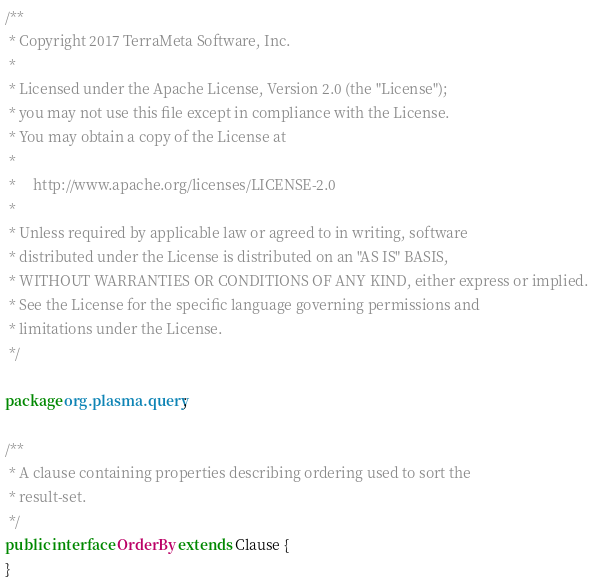Convert code to text. <code><loc_0><loc_0><loc_500><loc_500><_Java_>/**
 * Copyright 2017 TerraMeta Software, Inc.
 * 
 * Licensed under the Apache License, Version 2.0 (the "License");
 * you may not use this file except in compliance with the License.
 * You may obtain a copy of the License at
 * 
 *     http://www.apache.org/licenses/LICENSE-2.0
 * 
 * Unless required by applicable law or agreed to in writing, software
 * distributed under the License is distributed on an "AS IS" BASIS,
 * WITHOUT WARRANTIES OR CONDITIONS OF ANY KIND, either express or implied.
 * See the License for the specific language governing permissions and
 * limitations under the License.
 */

package org.plasma.query;

/**
 * A clause containing properties describing ordering used to sort the
 * result-set.
 */
public interface OrderBy extends Clause {
}</code> 